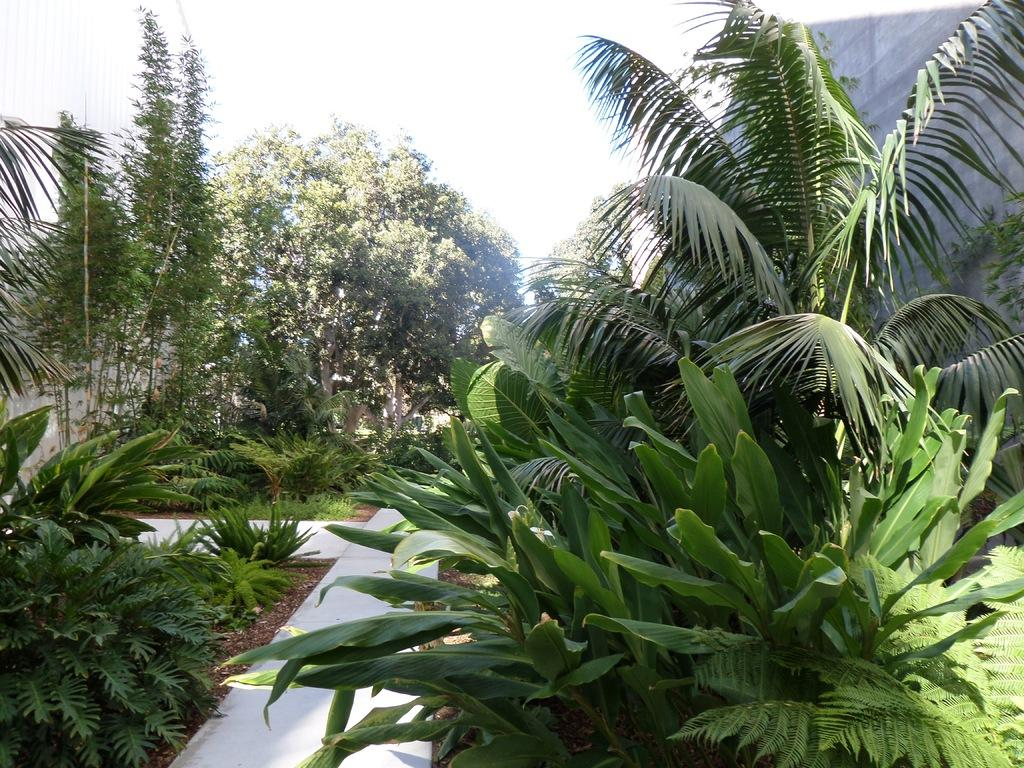What type of vegetation can be seen in the image? There are trees in the image. Where are the trees located in relation to other elements in the image? The trees are beside a pathway. What news is being reported by the beggar in the image? There is no beggar or news report present in the image; it only features trees beside a pathway. 